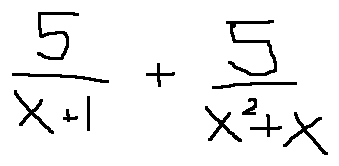<formula> <loc_0><loc_0><loc_500><loc_500>\frac { 5 } { x + 1 } + \frac { 5 } { x ^ { 2 } + x }</formula> 